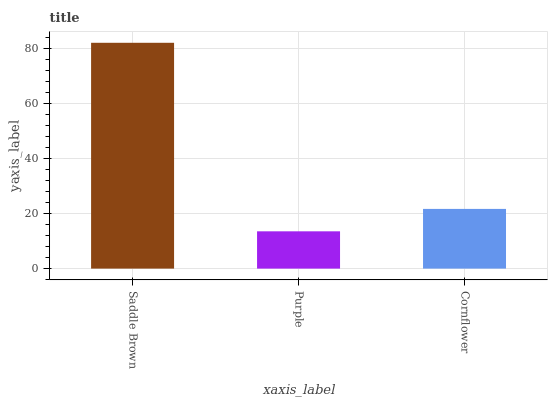Is Purple the minimum?
Answer yes or no. Yes. Is Saddle Brown the maximum?
Answer yes or no. Yes. Is Cornflower the minimum?
Answer yes or no. No. Is Cornflower the maximum?
Answer yes or no. No. Is Cornflower greater than Purple?
Answer yes or no. Yes. Is Purple less than Cornflower?
Answer yes or no. Yes. Is Purple greater than Cornflower?
Answer yes or no. No. Is Cornflower less than Purple?
Answer yes or no. No. Is Cornflower the high median?
Answer yes or no. Yes. Is Cornflower the low median?
Answer yes or no. Yes. Is Purple the high median?
Answer yes or no. No. Is Saddle Brown the low median?
Answer yes or no. No. 